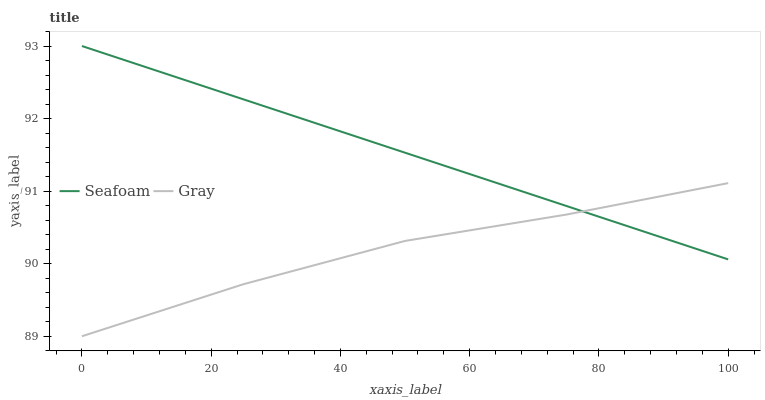Does Gray have the minimum area under the curve?
Answer yes or no. Yes. Does Seafoam have the maximum area under the curve?
Answer yes or no. Yes. Does Seafoam have the minimum area under the curve?
Answer yes or no. No. Is Seafoam the smoothest?
Answer yes or no. Yes. Is Gray the roughest?
Answer yes or no. Yes. Is Seafoam the roughest?
Answer yes or no. No. Does Gray have the lowest value?
Answer yes or no. Yes. Does Seafoam have the lowest value?
Answer yes or no. No. Does Seafoam have the highest value?
Answer yes or no. Yes. Does Seafoam intersect Gray?
Answer yes or no. Yes. Is Seafoam less than Gray?
Answer yes or no. No. Is Seafoam greater than Gray?
Answer yes or no. No. 